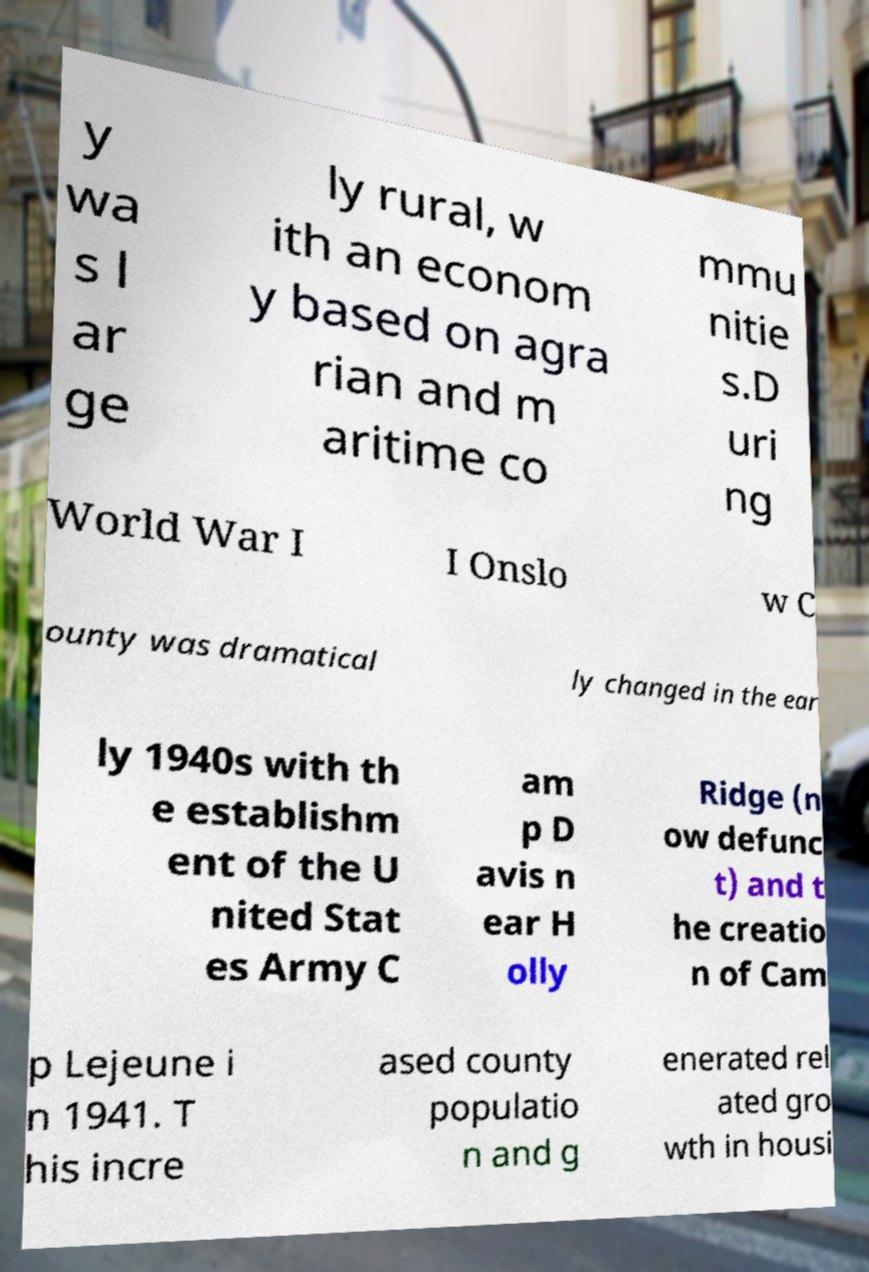Could you assist in decoding the text presented in this image and type it out clearly? y wa s l ar ge ly rural, w ith an econom y based on agra rian and m aritime co mmu nitie s.D uri ng World War I I Onslo w C ounty was dramatical ly changed in the ear ly 1940s with th e establishm ent of the U nited Stat es Army C am p D avis n ear H olly Ridge (n ow defunc t) and t he creatio n of Cam p Lejeune i n 1941. T his incre ased county populatio n and g enerated rel ated gro wth in housi 